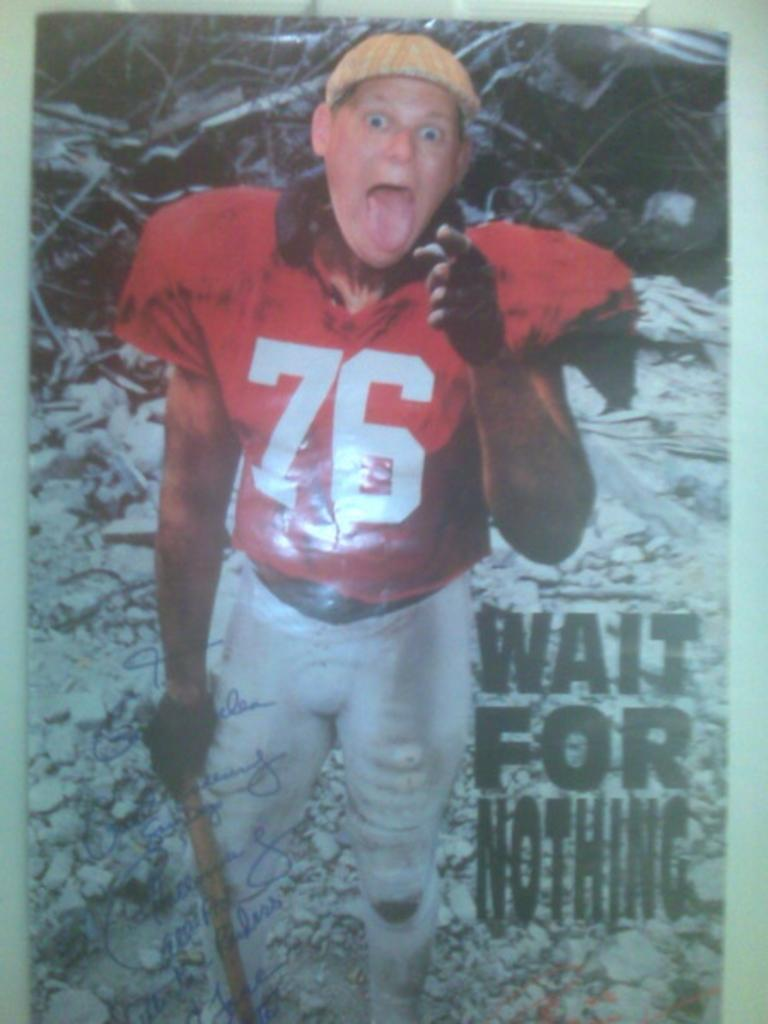<image>
Create a compact narrative representing the image presented. A man is wearing a red jersey with the number 76 on it. 